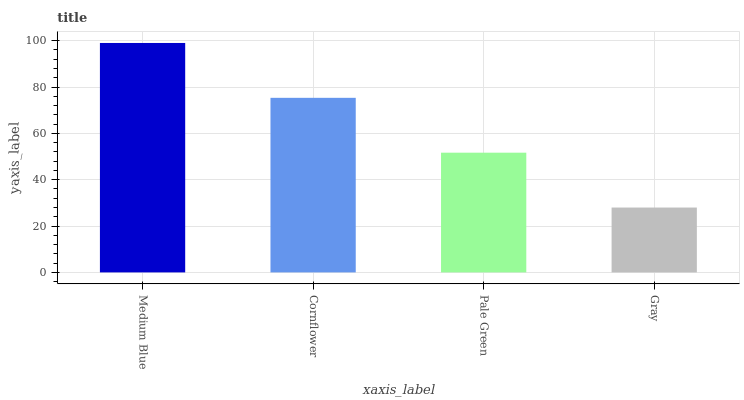Is Gray the minimum?
Answer yes or no. Yes. Is Medium Blue the maximum?
Answer yes or no. Yes. Is Cornflower the minimum?
Answer yes or no. No. Is Cornflower the maximum?
Answer yes or no. No. Is Medium Blue greater than Cornflower?
Answer yes or no. Yes. Is Cornflower less than Medium Blue?
Answer yes or no. Yes. Is Cornflower greater than Medium Blue?
Answer yes or no. No. Is Medium Blue less than Cornflower?
Answer yes or no. No. Is Cornflower the high median?
Answer yes or no. Yes. Is Pale Green the low median?
Answer yes or no. Yes. Is Gray the high median?
Answer yes or no. No. Is Medium Blue the low median?
Answer yes or no. No. 